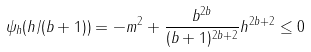<formula> <loc_0><loc_0><loc_500><loc_500>\psi _ { h } ( h / ( b + 1 ) ) = - m ^ { 2 } + \frac { b ^ { 2 b } } { ( b + 1 ) ^ { 2 b + 2 } } h ^ { 2 b + 2 } \leq 0</formula> 